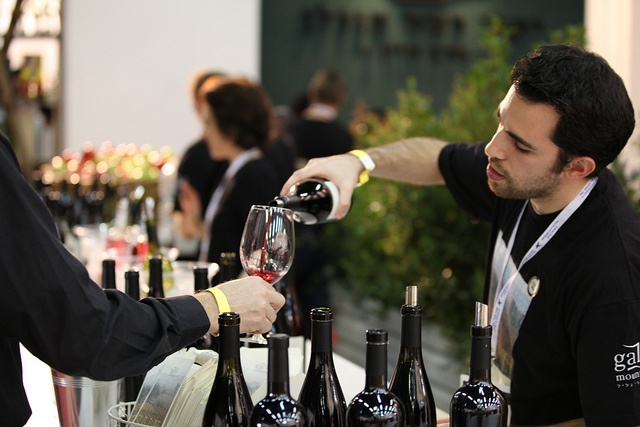Describe the objects in this image and their specific colors. I can see people in white, black, gray, darkgray, and maroon tones, people in white, black, and tan tones, people in white, black, gray, and maroon tones, people in white, black, and gray tones, and bottle in white, black, gray, lightgray, and darkgray tones in this image. 